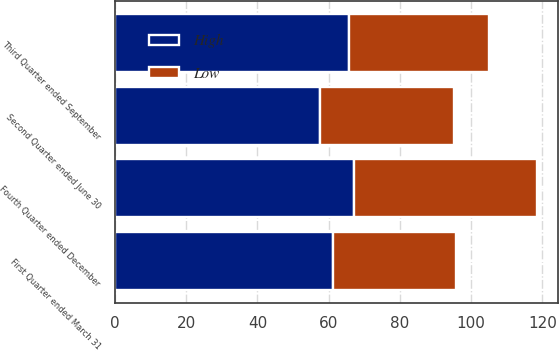Convert chart to OTSL. <chart><loc_0><loc_0><loc_500><loc_500><stacked_bar_chart><ecel><fcel>First Quarter ended March 31<fcel>Second Quarter ended June 30<fcel>Third Quarter ended September<fcel>Fourth Quarter ended December<nl><fcel>High<fcel>61.18<fcel>57.51<fcel>65.77<fcel>67<nl><fcel>Low<fcel>34.67<fcel>37.58<fcel>39.19<fcel>51.34<nl></chart> 